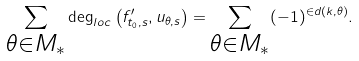<formula> <loc_0><loc_0><loc_500><loc_500>\sum _ { \substack { \theta \in M _ { * } } } \deg _ { l o c } \left ( f _ { t _ { 0 } , s } ^ { \prime } , u _ { \theta , s } \right ) = \sum _ { \substack { \theta \in M _ { * } } } ( - 1 ) ^ { \in d ( k , \theta ) } .</formula> 